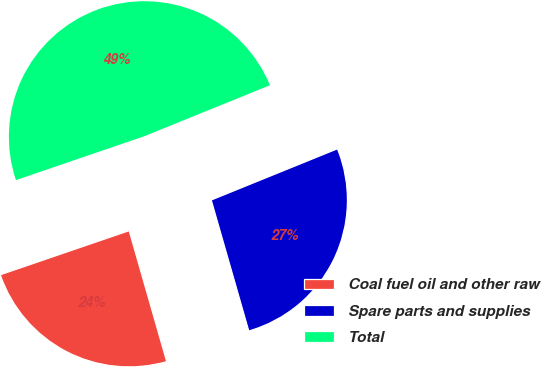Convert chart. <chart><loc_0><loc_0><loc_500><loc_500><pie_chart><fcel>Coal fuel oil and other raw<fcel>Spare parts and supplies<fcel>Total<nl><fcel>24.2%<fcel>26.69%<fcel>49.11%<nl></chart> 